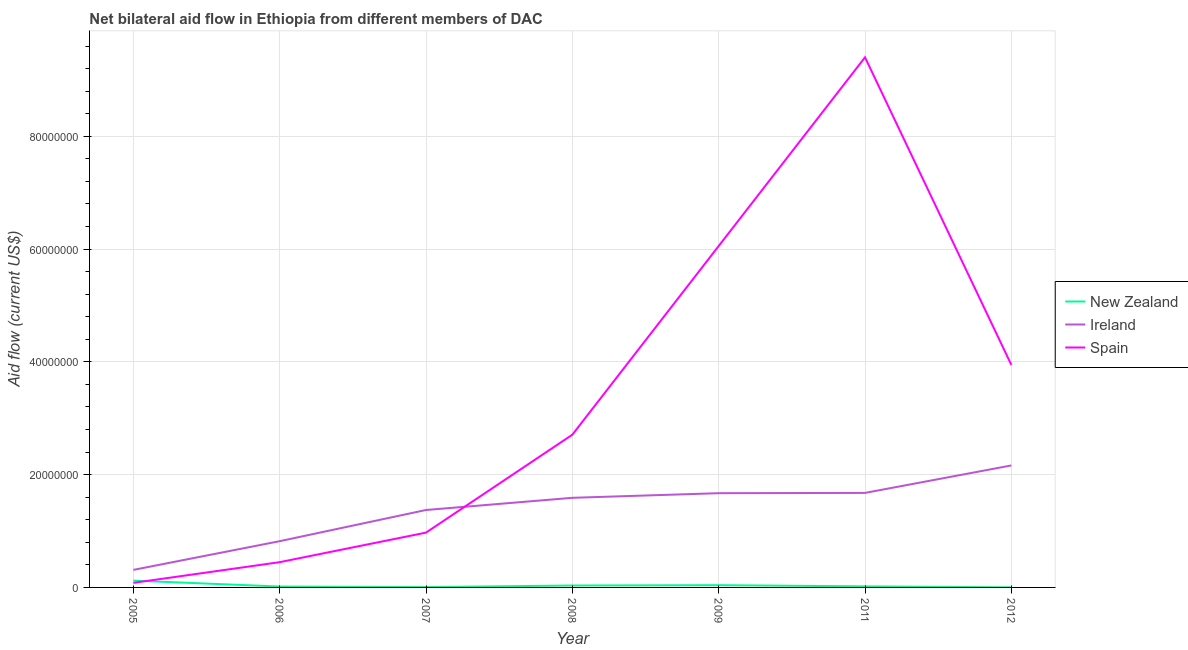What is the amount of aid provided by spain in 2008?
Your answer should be compact. 2.71e+07. Across all years, what is the maximum amount of aid provided by new zealand?
Ensure brevity in your answer.  1.21e+06. Across all years, what is the minimum amount of aid provided by new zealand?
Your answer should be compact. 2.00e+04. In which year was the amount of aid provided by spain maximum?
Make the answer very short. 2011. What is the total amount of aid provided by new zealand in the graph?
Offer a very short reply. 2.38e+06. What is the difference between the amount of aid provided by spain in 2009 and that in 2012?
Ensure brevity in your answer.  2.11e+07. What is the difference between the amount of aid provided by spain in 2007 and the amount of aid provided by new zealand in 2011?
Give a very brief answer. 9.53e+06. In the year 2007, what is the difference between the amount of aid provided by spain and amount of aid provided by new zealand?
Give a very brief answer. 9.66e+06. In how many years, is the amount of aid provided by new zealand greater than 28000000 US$?
Offer a very short reply. 0. What is the ratio of the amount of aid provided by spain in 2005 to that in 2007?
Make the answer very short. 0.08. Is the amount of aid provided by new zealand in 2008 less than that in 2012?
Give a very brief answer. No. Is the difference between the amount of aid provided by spain in 2011 and 2012 greater than the difference between the amount of aid provided by ireland in 2011 and 2012?
Ensure brevity in your answer.  Yes. What is the difference between the highest and the second highest amount of aid provided by new zealand?
Ensure brevity in your answer.  8.10e+05. What is the difference between the highest and the lowest amount of aid provided by ireland?
Provide a succinct answer. 1.85e+07. In how many years, is the amount of aid provided by new zealand greater than the average amount of aid provided by new zealand taken over all years?
Offer a very short reply. 2. Is it the case that in every year, the sum of the amount of aid provided by new zealand and amount of aid provided by ireland is greater than the amount of aid provided by spain?
Offer a terse response. No. Does the amount of aid provided by ireland monotonically increase over the years?
Your answer should be very brief. Yes. Is the amount of aid provided by ireland strictly less than the amount of aid provided by spain over the years?
Offer a very short reply. No. How many lines are there?
Your answer should be compact. 3. How many years are there in the graph?
Your response must be concise. 7. What is the difference between two consecutive major ticks on the Y-axis?
Your response must be concise. 2.00e+07. Are the values on the major ticks of Y-axis written in scientific E-notation?
Ensure brevity in your answer.  No. Does the graph contain any zero values?
Your response must be concise. No. Does the graph contain grids?
Provide a short and direct response. Yes. Where does the legend appear in the graph?
Your response must be concise. Center right. How many legend labels are there?
Keep it short and to the point. 3. What is the title of the graph?
Ensure brevity in your answer.  Net bilateral aid flow in Ethiopia from different members of DAC. What is the Aid flow (current US$) of New Zealand in 2005?
Your response must be concise. 1.21e+06. What is the Aid flow (current US$) in Ireland in 2005?
Ensure brevity in your answer.  3.11e+06. What is the Aid flow (current US$) in Spain in 2005?
Your answer should be very brief. 8.10e+05. What is the Aid flow (current US$) in New Zealand in 2006?
Your response must be concise. 1.60e+05. What is the Aid flow (current US$) in Ireland in 2006?
Offer a very short reply. 8.20e+06. What is the Aid flow (current US$) of Spain in 2006?
Provide a short and direct response. 4.48e+06. What is the Aid flow (current US$) in Ireland in 2007?
Your response must be concise. 1.37e+07. What is the Aid flow (current US$) of Spain in 2007?
Offer a very short reply. 9.72e+06. What is the Aid flow (current US$) of New Zealand in 2008?
Your answer should be compact. 3.40e+05. What is the Aid flow (current US$) in Ireland in 2008?
Your answer should be compact. 1.59e+07. What is the Aid flow (current US$) of Spain in 2008?
Ensure brevity in your answer.  2.71e+07. What is the Aid flow (current US$) of Ireland in 2009?
Ensure brevity in your answer.  1.67e+07. What is the Aid flow (current US$) of Spain in 2009?
Make the answer very short. 6.05e+07. What is the Aid flow (current US$) in New Zealand in 2011?
Offer a terse response. 1.90e+05. What is the Aid flow (current US$) in Ireland in 2011?
Give a very brief answer. 1.68e+07. What is the Aid flow (current US$) in Spain in 2011?
Provide a succinct answer. 9.40e+07. What is the Aid flow (current US$) in New Zealand in 2012?
Keep it short and to the point. 2.00e+04. What is the Aid flow (current US$) in Ireland in 2012?
Ensure brevity in your answer.  2.16e+07. What is the Aid flow (current US$) of Spain in 2012?
Provide a short and direct response. 3.95e+07. Across all years, what is the maximum Aid flow (current US$) of New Zealand?
Offer a very short reply. 1.21e+06. Across all years, what is the maximum Aid flow (current US$) in Ireland?
Offer a terse response. 2.16e+07. Across all years, what is the maximum Aid flow (current US$) in Spain?
Your answer should be very brief. 9.40e+07. Across all years, what is the minimum Aid flow (current US$) in New Zealand?
Make the answer very short. 2.00e+04. Across all years, what is the minimum Aid flow (current US$) of Ireland?
Offer a terse response. 3.11e+06. Across all years, what is the minimum Aid flow (current US$) in Spain?
Give a very brief answer. 8.10e+05. What is the total Aid flow (current US$) of New Zealand in the graph?
Your response must be concise. 2.38e+06. What is the total Aid flow (current US$) in Ireland in the graph?
Your answer should be very brief. 9.60e+07. What is the total Aid flow (current US$) in Spain in the graph?
Offer a terse response. 2.36e+08. What is the difference between the Aid flow (current US$) in New Zealand in 2005 and that in 2006?
Make the answer very short. 1.05e+06. What is the difference between the Aid flow (current US$) of Ireland in 2005 and that in 2006?
Provide a succinct answer. -5.09e+06. What is the difference between the Aid flow (current US$) of Spain in 2005 and that in 2006?
Keep it short and to the point. -3.67e+06. What is the difference between the Aid flow (current US$) of New Zealand in 2005 and that in 2007?
Offer a very short reply. 1.15e+06. What is the difference between the Aid flow (current US$) in Ireland in 2005 and that in 2007?
Your response must be concise. -1.06e+07. What is the difference between the Aid flow (current US$) of Spain in 2005 and that in 2007?
Make the answer very short. -8.91e+06. What is the difference between the Aid flow (current US$) in New Zealand in 2005 and that in 2008?
Your answer should be very brief. 8.70e+05. What is the difference between the Aid flow (current US$) in Ireland in 2005 and that in 2008?
Offer a very short reply. -1.28e+07. What is the difference between the Aid flow (current US$) of Spain in 2005 and that in 2008?
Your response must be concise. -2.63e+07. What is the difference between the Aid flow (current US$) of New Zealand in 2005 and that in 2009?
Provide a short and direct response. 8.10e+05. What is the difference between the Aid flow (current US$) of Ireland in 2005 and that in 2009?
Your response must be concise. -1.36e+07. What is the difference between the Aid flow (current US$) of Spain in 2005 and that in 2009?
Give a very brief answer. -5.97e+07. What is the difference between the Aid flow (current US$) in New Zealand in 2005 and that in 2011?
Give a very brief answer. 1.02e+06. What is the difference between the Aid flow (current US$) of Ireland in 2005 and that in 2011?
Make the answer very short. -1.36e+07. What is the difference between the Aid flow (current US$) in Spain in 2005 and that in 2011?
Keep it short and to the point. -9.32e+07. What is the difference between the Aid flow (current US$) of New Zealand in 2005 and that in 2012?
Your answer should be very brief. 1.19e+06. What is the difference between the Aid flow (current US$) in Ireland in 2005 and that in 2012?
Make the answer very short. -1.85e+07. What is the difference between the Aid flow (current US$) in Spain in 2005 and that in 2012?
Ensure brevity in your answer.  -3.86e+07. What is the difference between the Aid flow (current US$) in New Zealand in 2006 and that in 2007?
Provide a short and direct response. 1.00e+05. What is the difference between the Aid flow (current US$) of Ireland in 2006 and that in 2007?
Offer a very short reply. -5.53e+06. What is the difference between the Aid flow (current US$) in Spain in 2006 and that in 2007?
Offer a terse response. -5.24e+06. What is the difference between the Aid flow (current US$) in New Zealand in 2006 and that in 2008?
Provide a short and direct response. -1.80e+05. What is the difference between the Aid flow (current US$) in Ireland in 2006 and that in 2008?
Your answer should be compact. -7.69e+06. What is the difference between the Aid flow (current US$) in Spain in 2006 and that in 2008?
Your response must be concise. -2.26e+07. What is the difference between the Aid flow (current US$) of Ireland in 2006 and that in 2009?
Give a very brief answer. -8.51e+06. What is the difference between the Aid flow (current US$) of Spain in 2006 and that in 2009?
Your answer should be very brief. -5.61e+07. What is the difference between the Aid flow (current US$) in Ireland in 2006 and that in 2011?
Your answer should be compact. -8.56e+06. What is the difference between the Aid flow (current US$) of Spain in 2006 and that in 2011?
Provide a succinct answer. -8.95e+07. What is the difference between the Aid flow (current US$) of New Zealand in 2006 and that in 2012?
Your answer should be compact. 1.40e+05. What is the difference between the Aid flow (current US$) of Ireland in 2006 and that in 2012?
Offer a terse response. -1.34e+07. What is the difference between the Aid flow (current US$) in Spain in 2006 and that in 2012?
Your response must be concise. -3.50e+07. What is the difference between the Aid flow (current US$) in New Zealand in 2007 and that in 2008?
Make the answer very short. -2.80e+05. What is the difference between the Aid flow (current US$) in Ireland in 2007 and that in 2008?
Provide a succinct answer. -2.16e+06. What is the difference between the Aid flow (current US$) of Spain in 2007 and that in 2008?
Your answer should be compact. -1.74e+07. What is the difference between the Aid flow (current US$) of Ireland in 2007 and that in 2009?
Offer a terse response. -2.98e+06. What is the difference between the Aid flow (current US$) of Spain in 2007 and that in 2009?
Provide a succinct answer. -5.08e+07. What is the difference between the Aid flow (current US$) in New Zealand in 2007 and that in 2011?
Your response must be concise. -1.30e+05. What is the difference between the Aid flow (current US$) in Ireland in 2007 and that in 2011?
Ensure brevity in your answer.  -3.03e+06. What is the difference between the Aid flow (current US$) in Spain in 2007 and that in 2011?
Provide a short and direct response. -8.43e+07. What is the difference between the Aid flow (current US$) of Ireland in 2007 and that in 2012?
Your response must be concise. -7.90e+06. What is the difference between the Aid flow (current US$) in Spain in 2007 and that in 2012?
Your response must be concise. -2.97e+07. What is the difference between the Aid flow (current US$) of Ireland in 2008 and that in 2009?
Ensure brevity in your answer.  -8.20e+05. What is the difference between the Aid flow (current US$) in Spain in 2008 and that in 2009?
Provide a short and direct response. -3.35e+07. What is the difference between the Aid flow (current US$) in New Zealand in 2008 and that in 2011?
Your answer should be compact. 1.50e+05. What is the difference between the Aid flow (current US$) in Ireland in 2008 and that in 2011?
Your answer should be very brief. -8.70e+05. What is the difference between the Aid flow (current US$) in Spain in 2008 and that in 2011?
Provide a succinct answer. -6.69e+07. What is the difference between the Aid flow (current US$) in New Zealand in 2008 and that in 2012?
Make the answer very short. 3.20e+05. What is the difference between the Aid flow (current US$) of Ireland in 2008 and that in 2012?
Keep it short and to the point. -5.74e+06. What is the difference between the Aid flow (current US$) of Spain in 2008 and that in 2012?
Offer a terse response. -1.24e+07. What is the difference between the Aid flow (current US$) in Ireland in 2009 and that in 2011?
Your answer should be compact. -5.00e+04. What is the difference between the Aid flow (current US$) of Spain in 2009 and that in 2011?
Provide a succinct answer. -3.35e+07. What is the difference between the Aid flow (current US$) of Ireland in 2009 and that in 2012?
Your answer should be compact. -4.92e+06. What is the difference between the Aid flow (current US$) in Spain in 2009 and that in 2012?
Your response must be concise. 2.11e+07. What is the difference between the Aid flow (current US$) in New Zealand in 2011 and that in 2012?
Provide a succinct answer. 1.70e+05. What is the difference between the Aid flow (current US$) in Ireland in 2011 and that in 2012?
Your response must be concise. -4.87e+06. What is the difference between the Aid flow (current US$) in Spain in 2011 and that in 2012?
Offer a very short reply. 5.45e+07. What is the difference between the Aid flow (current US$) in New Zealand in 2005 and the Aid flow (current US$) in Ireland in 2006?
Your answer should be very brief. -6.99e+06. What is the difference between the Aid flow (current US$) in New Zealand in 2005 and the Aid flow (current US$) in Spain in 2006?
Offer a terse response. -3.27e+06. What is the difference between the Aid flow (current US$) of Ireland in 2005 and the Aid flow (current US$) of Spain in 2006?
Provide a succinct answer. -1.37e+06. What is the difference between the Aid flow (current US$) of New Zealand in 2005 and the Aid flow (current US$) of Ireland in 2007?
Offer a very short reply. -1.25e+07. What is the difference between the Aid flow (current US$) of New Zealand in 2005 and the Aid flow (current US$) of Spain in 2007?
Provide a short and direct response. -8.51e+06. What is the difference between the Aid flow (current US$) in Ireland in 2005 and the Aid flow (current US$) in Spain in 2007?
Your answer should be very brief. -6.61e+06. What is the difference between the Aid flow (current US$) of New Zealand in 2005 and the Aid flow (current US$) of Ireland in 2008?
Your answer should be compact. -1.47e+07. What is the difference between the Aid flow (current US$) in New Zealand in 2005 and the Aid flow (current US$) in Spain in 2008?
Provide a short and direct response. -2.59e+07. What is the difference between the Aid flow (current US$) in Ireland in 2005 and the Aid flow (current US$) in Spain in 2008?
Offer a terse response. -2.40e+07. What is the difference between the Aid flow (current US$) in New Zealand in 2005 and the Aid flow (current US$) in Ireland in 2009?
Your response must be concise. -1.55e+07. What is the difference between the Aid flow (current US$) in New Zealand in 2005 and the Aid flow (current US$) in Spain in 2009?
Make the answer very short. -5.93e+07. What is the difference between the Aid flow (current US$) of Ireland in 2005 and the Aid flow (current US$) of Spain in 2009?
Keep it short and to the point. -5.74e+07. What is the difference between the Aid flow (current US$) of New Zealand in 2005 and the Aid flow (current US$) of Ireland in 2011?
Your answer should be very brief. -1.56e+07. What is the difference between the Aid flow (current US$) in New Zealand in 2005 and the Aid flow (current US$) in Spain in 2011?
Keep it short and to the point. -9.28e+07. What is the difference between the Aid flow (current US$) of Ireland in 2005 and the Aid flow (current US$) of Spain in 2011?
Keep it short and to the point. -9.09e+07. What is the difference between the Aid flow (current US$) in New Zealand in 2005 and the Aid flow (current US$) in Ireland in 2012?
Your response must be concise. -2.04e+07. What is the difference between the Aid flow (current US$) in New Zealand in 2005 and the Aid flow (current US$) in Spain in 2012?
Offer a terse response. -3.82e+07. What is the difference between the Aid flow (current US$) in Ireland in 2005 and the Aid flow (current US$) in Spain in 2012?
Your response must be concise. -3.64e+07. What is the difference between the Aid flow (current US$) in New Zealand in 2006 and the Aid flow (current US$) in Ireland in 2007?
Your response must be concise. -1.36e+07. What is the difference between the Aid flow (current US$) of New Zealand in 2006 and the Aid flow (current US$) of Spain in 2007?
Give a very brief answer. -9.56e+06. What is the difference between the Aid flow (current US$) of Ireland in 2006 and the Aid flow (current US$) of Spain in 2007?
Make the answer very short. -1.52e+06. What is the difference between the Aid flow (current US$) in New Zealand in 2006 and the Aid flow (current US$) in Ireland in 2008?
Offer a terse response. -1.57e+07. What is the difference between the Aid flow (current US$) of New Zealand in 2006 and the Aid flow (current US$) of Spain in 2008?
Provide a short and direct response. -2.69e+07. What is the difference between the Aid flow (current US$) in Ireland in 2006 and the Aid flow (current US$) in Spain in 2008?
Offer a very short reply. -1.89e+07. What is the difference between the Aid flow (current US$) in New Zealand in 2006 and the Aid flow (current US$) in Ireland in 2009?
Provide a short and direct response. -1.66e+07. What is the difference between the Aid flow (current US$) of New Zealand in 2006 and the Aid flow (current US$) of Spain in 2009?
Ensure brevity in your answer.  -6.04e+07. What is the difference between the Aid flow (current US$) in Ireland in 2006 and the Aid flow (current US$) in Spain in 2009?
Ensure brevity in your answer.  -5.23e+07. What is the difference between the Aid flow (current US$) of New Zealand in 2006 and the Aid flow (current US$) of Ireland in 2011?
Provide a short and direct response. -1.66e+07. What is the difference between the Aid flow (current US$) in New Zealand in 2006 and the Aid flow (current US$) in Spain in 2011?
Give a very brief answer. -9.38e+07. What is the difference between the Aid flow (current US$) in Ireland in 2006 and the Aid flow (current US$) in Spain in 2011?
Offer a very short reply. -8.58e+07. What is the difference between the Aid flow (current US$) in New Zealand in 2006 and the Aid flow (current US$) in Ireland in 2012?
Give a very brief answer. -2.15e+07. What is the difference between the Aid flow (current US$) of New Zealand in 2006 and the Aid flow (current US$) of Spain in 2012?
Provide a succinct answer. -3.93e+07. What is the difference between the Aid flow (current US$) in Ireland in 2006 and the Aid flow (current US$) in Spain in 2012?
Provide a short and direct response. -3.13e+07. What is the difference between the Aid flow (current US$) in New Zealand in 2007 and the Aid flow (current US$) in Ireland in 2008?
Make the answer very short. -1.58e+07. What is the difference between the Aid flow (current US$) in New Zealand in 2007 and the Aid flow (current US$) in Spain in 2008?
Your response must be concise. -2.70e+07. What is the difference between the Aid flow (current US$) of Ireland in 2007 and the Aid flow (current US$) of Spain in 2008?
Your answer should be very brief. -1.34e+07. What is the difference between the Aid flow (current US$) of New Zealand in 2007 and the Aid flow (current US$) of Ireland in 2009?
Provide a short and direct response. -1.66e+07. What is the difference between the Aid flow (current US$) of New Zealand in 2007 and the Aid flow (current US$) of Spain in 2009?
Provide a short and direct response. -6.05e+07. What is the difference between the Aid flow (current US$) in Ireland in 2007 and the Aid flow (current US$) in Spain in 2009?
Give a very brief answer. -4.68e+07. What is the difference between the Aid flow (current US$) of New Zealand in 2007 and the Aid flow (current US$) of Ireland in 2011?
Give a very brief answer. -1.67e+07. What is the difference between the Aid flow (current US$) in New Zealand in 2007 and the Aid flow (current US$) in Spain in 2011?
Ensure brevity in your answer.  -9.39e+07. What is the difference between the Aid flow (current US$) of Ireland in 2007 and the Aid flow (current US$) of Spain in 2011?
Provide a short and direct response. -8.03e+07. What is the difference between the Aid flow (current US$) of New Zealand in 2007 and the Aid flow (current US$) of Ireland in 2012?
Give a very brief answer. -2.16e+07. What is the difference between the Aid flow (current US$) in New Zealand in 2007 and the Aid flow (current US$) in Spain in 2012?
Keep it short and to the point. -3.94e+07. What is the difference between the Aid flow (current US$) in Ireland in 2007 and the Aid flow (current US$) in Spain in 2012?
Give a very brief answer. -2.57e+07. What is the difference between the Aid flow (current US$) in New Zealand in 2008 and the Aid flow (current US$) in Ireland in 2009?
Offer a very short reply. -1.64e+07. What is the difference between the Aid flow (current US$) in New Zealand in 2008 and the Aid flow (current US$) in Spain in 2009?
Ensure brevity in your answer.  -6.02e+07. What is the difference between the Aid flow (current US$) of Ireland in 2008 and the Aid flow (current US$) of Spain in 2009?
Provide a succinct answer. -4.46e+07. What is the difference between the Aid flow (current US$) in New Zealand in 2008 and the Aid flow (current US$) in Ireland in 2011?
Your answer should be compact. -1.64e+07. What is the difference between the Aid flow (current US$) in New Zealand in 2008 and the Aid flow (current US$) in Spain in 2011?
Your answer should be very brief. -9.37e+07. What is the difference between the Aid flow (current US$) of Ireland in 2008 and the Aid flow (current US$) of Spain in 2011?
Keep it short and to the point. -7.81e+07. What is the difference between the Aid flow (current US$) in New Zealand in 2008 and the Aid flow (current US$) in Ireland in 2012?
Give a very brief answer. -2.13e+07. What is the difference between the Aid flow (current US$) in New Zealand in 2008 and the Aid flow (current US$) in Spain in 2012?
Offer a terse response. -3.91e+07. What is the difference between the Aid flow (current US$) of Ireland in 2008 and the Aid flow (current US$) of Spain in 2012?
Your response must be concise. -2.36e+07. What is the difference between the Aid flow (current US$) of New Zealand in 2009 and the Aid flow (current US$) of Ireland in 2011?
Give a very brief answer. -1.64e+07. What is the difference between the Aid flow (current US$) in New Zealand in 2009 and the Aid flow (current US$) in Spain in 2011?
Give a very brief answer. -9.36e+07. What is the difference between the Aid flow (current US$) in Ireland in 2009 and the Aid flow (current US$) in Spain in 2011?
Ensure brevity in your answer.  -7.73e+07. What is the difference between the Aid flow (current US$) of New Zealand in 2009 and the Aid flow (current US$) of Ireland in 2012?
Your response must be concise. -2.12e+07. What is the difference between the Aid flow (current US$) in New Zealand in 2009 and the Aid flow (current US$) in Spain in 2012?
Keep it short and to the point. -3.91e+07. What is the difference between the Aid flow (current US$) in Ireland in 2009 and the Aid flow (current US$) in Spain in 2012?
Provide a succinct answer. -2.28e+07. What is the difference between the Aid flow (current US$) of New Zealand in 2011 and the Aid flow (current US$) of Ireland in 2012?
Your answer should be compact. -2.14e+07. What is the difference between the Aid flow (current US$) of New Zealand in 2011 and the Aid flow (current US$) of Spain in 2012?
Provide a short and direct response. -3.93e+07. What is the difference between the Aid flow (current US$) in Ireland in 2011 and the Aid flow (current US$) in Spain in 2012?
Keep it short and to the point. -2.27e+07. What is the average Aid flow (current US$) in Ireland per year?
Ensure brevity in your answer.  1.37e+07. What is the average Aid flow (current US$) in Spain per year?
Provide a short and direct response. 3.37e+07. In the year 2005, what is the difference between the Aid flow (current US$) in New Zealand and Aid flow (current US$) in Ireland?
Provide a short and direct response. -1.90e+06. In the year 2005, what is the difference between the Aid flow (current US$) of New Zealand and Aid flow (current US$) of Spain?
Your answer should be very brief. 4.00e+05. In the year 2005, what is the difference between the Aid flow (current US$) in Ireland and Aid flow (current US$) in Spain?
Offer a very short reply. 2.30e+06. In the year 2006, what is the difference between the Aid flow (current US$) of New Zealand and Aid flow (current US$) of Ireland?
Give a very brief answer. -8.04e+06. In the year 2006, what is the difference between the Aid flow (current US$) in New Zealand and Aid flow (current US$) in Spain?
Your answer should be very brief. -4.32e+06. In the year 2006, what is the difference between the Aid flow (current US$) of Ireland and Aid flow (current US$) of Spain?
Offer a very short reply. 3.72e+06. In the year 2007, what is the difference between the Aid flow (current US$) of New Zealand and Aid flow (current US$) of Ireland?
Provide a succinct answer. -1.37e+07. In the year 2007, what is the difference between the Aid flow (current US$) of New Zealand and Aid flow (current US$) of Spain?
Keep it short and to the point. -9.66e+06. In the year 2007, what is the difference between the Aid flow (current US$) of Ireland and Aid flow (current US$) of Spain?
Your response must be concise. 4.01e+06. In the year 2008, what is the difference between the Aid flow (current US$) in New Zealand and Aid flow (current US$) in Ireland?
Offer a terse response. -1.56e+07. In the year 2008, what is the difference between the Aid flow (current US$) in New Zealand and Aid flow (current US$) in Spain?
Give a very brief answer. -2.67e+07. In the year 2008, what is the difference between the Aid flow (current US$) in Ireland and Aid flow (current US$) in Spain?
Provide a succinct answer. -1.12e+07. In the year 2009, what is the difference between the Aid flow (current US$) in New Zealand and Aid flow (current US$) in Ireland?
Your answer should be compact. -1.63e+07. In the year 2009, what is the difference between the Aid flow (current US$) of New Zealand and Aid flow (current US$) of Spain?
Give a very brief answer. -6.01e+07. In the year 2009, what is the difference between the Aid flow (current US$) of Ireland and Aid flow (current US$) of Spain?
Ensure brevity in your answer.  -4.38e+07. In the year 2011, what is the difference between the Aid flow (current US$) of New Zealand and Aid flow (current US$) of Ireland?
Your answer should be very brief. -1.66e+07. In the year 2011, what is the difference between the Aid flow (current US$) in New Zealand and Aid flow (current US$) in Spain?
Offer a terse response. -9.38e+07. In the year 2011, what is the difference between the Aid flow (current US$) of Ireland and Aid flow (current US$) of Spain?
Your answer should be compact. -7.72e+07. In the year 2012, what is the difference between the Aid flow (current US$) in New Zealand and Aid flow (current US$) in Ireland?
Offer a very short reply. -2.16e+07. In the year 2012, what is the difference between the Aid flow (current US$) of New Zealand and Aid flow (current US$) of Spain?
Provide a succinct answer. -3.94e+07. In the year 2012, what is the difference between the Aid flow (current US$) in Ireland and Aid flow (current US$) in Spain?
Offer a very short reply. -1.78e+07. What is the ratio of the Aid flow (current US$) in New Zealand in 2005 to that in 2006?
Ensure brevity in your answer.  7.56. What is the ratio of the Aid flow (current US$) of Ireland in 2005 to that in 2006?
Your answer should be very brief. 0.38. What is the ratio of the Aid flow (current US$) in Spain in 2005 to that in 2006?
Provide a short and direct response. 0.18. What is the ratio of the Aid flow (current US$) in New Zealand in 2005 to that in 2007?
Your answer should be very brief. 20.17. What is the ratio of the Aid flow (current US$) of Ireland in 2005 to that in 2007?
Offer a terse response. 0.23. What is the ratio of the Aid flow (current US$) in Spain in 2005 to that in 2007?
Offer a terse response. 0.08. What is the ratio of the Aid flow (current US$) in New Zealand in 2005 to that in 2008?
Your response must be concise. 3.56. What is the ratio of the Aid flow (current US$) of Ireland in 2005 to that in 2008?
Ensure brevity in your answer.  0.2. What is the ratio of the Aid flow (current US$) in Spain in 2005 to that in 2008?
Offer a very short reply. 0.03. What is the ratio of the Aid flow (current US$) of New Zealand in 2005 to that in 2009?
Provide a short and direct response. 3.02. What is the ratio of the Aid flow (current US$) in Ireland in 2005 to that in 2009?
Provide a succinct answer. 0.19. What is the ratio of the Aid flow (current US$) of Spain in 2005 to that in 2009?
Make the answer very short. 0.01. What is the ratio of the Aid flow (current US$) of New Zealand in 2005 to that in 2011?
Provide a succinct answer. 6.37. What is the ratio of the Aid flow (current US$) of Ireland in 2005 to that in 2011?
Offer a terse response. 0.19. What is the ratio of the Aid flow (current US$) of Spain in 2005 to that in 2011?
Your answer should be very brief. 0.01. What is the ratio of the Aid flow (current US$) of New Zealand in 2005 to that in 2012?
Offer a terse response. 60.5. What is the ratio of the Aid flow (current US$) in Ireland in 2005 to that in 2012?
Ensure brevity in your answer.  0.14. What is the ratio of the Aid flow (current US$) in Spain in 2005 to that in 2012?
Ensure brevity in your answer.  0.02. What is the ratio of the Aid flow (current US$) of New Zealand in 2006 to that in 2007?
Make the answer very short. 2.67. What is the ratio of the Aid flow (current US$) in Ireland in 2006 to that in 2007?
Offer a terse response. 0.6. What is the ratio of the Aid flow (current US$) in Spain in 2006 to that in 2007?
Make the answer very short. 0.46. What is the ratio of the Aid flow (current US$) of New Zealand in 2006 to that in 2008?
Keep it short and to the point. 0.47. What is the ratio of the Aid flow (current US$) of Ireland in 2006 to that in 2008?
Your answer should be compact. 0.52. What is the ratio of the Aid flow (current US$) of Spain in 2006 to that in 2008?
Ensure brevity in your answer.  0.17. What is the ratio of the Aid flow (current US$) in Ireland in 2006 to that in 2009?
Make the answer very short. 0.49. What is the ratio of the Aid flow (current US$) of Spain in 2006 to that in 2009?
Your answer should be compact. 0.07. What is the ratio of the Aid flow (current US$) in New Zealand in 2006 to that in 2011?
Provide a succinct answer. 0.84. What is the ratio of the Aid flow (current US$) in Ireland in 2006 to that in 2011?
Make the answer very short. 0.49. What is the ratio of the Aid flow (current US$) in Spain in 2006 to that in 2011?
Provide a short and direct response. 0.05. What is the ratio of the Aid flow (current US$) of Ireland in 2006 to that in 2012?
Provide a succinct answer. 0.38. What is the ratio of the Aid flow (current US$) of Spain in 2006 to that in 2012?
Provide a short and direct response. 0.11. What is the ratio of the Aid flow (current US$) in New Zealand in 2007 to that in 2008?
Your answer should be compact. 0.18. What is the ratio of the Aid flow (current US$) in Ireland in 2007 to that in 2008?
Make the answer very short. 0.86. What is the ratio of the Aid flow (current US$) of Spain in 2007 to that in 2008?
Ensure brevity in your answer.  0.36. What is the ratio of the Aid flow (current US$) in New Zealand in 2007 to that in 2009?
Your answer should be compact. 0.15. What is the ratio of the Aid flow (current US$) in Ireland in 2007 to that in 2009?
Offer a very short reply. 0.82. What is the ratio of the Aid flow (current US$) in Spain in 2007 to that in 2009?
Offer a very short reply. 0.16. What is the ratio of the Aid flow (current US$) of New Zealand in 2007 to that in 2011?
Ensure brevity in your answer.  0.32. What is the ratio of the Aid flow (current US$) in Ireland in 2007 to that in 2011?
Give a very brief answer. 0.82. What is the ratio of the Aid flow (current US$) in Spain in 2007 to that in 2011?
Make the answer very short. 0.1. What is the ratio of the Aid flow (current US$) in Ireland in 2007 to that in 2012?
Your answer should be very brief. 0.63. What is the ratio of the Aid flow (current US$) of Spain in 2007 to that in 2012?
Make the answer very short. 0.25. What is the ratio of the Aid flow (current US$) of Ireland in 2008 to that in 2009?
Your answer should be very brief. 0.95. What is the ratio of the Aid flow (current US$) in Spain in 2008 to that in 2009?
Make the answer very short. 0.45. What is the ratio of the Aid flow (current US$) in New Zealand in 2008 to that in 2011?
Offer a terse response. 1.79. What is the ratio of the Aid flow (current US$) in Ireland in 2008 to that in 2011?
Provide a short and direct response. 0.95. What is the ratio of the Aid flow (current US$) of Spain in 2008 to that in 2011?
Provide a short and direct response. 0.29. What is the ratio of the Aid flow (current US$) of New Zealand in 2008 to that in 2012?
Offer a very short reply. 17. What is the ratio of the Aid flow (current US$) of Ireland in 2008 to that in 2012?
Offer a very short reply. 0.73. What is the ratio of the Aid flow (current US$) of Spain in 2008 to that in 2012?
Provide a succinct answer. 0.69. What is the ratio of the Aid flow (current US$) of New Zealand in 2009 to that in 2011?
Offer a terse response. 2.11. What is the ratio of the Aid flow (current US$) of Spain in 2009 to that in 2011?
Make the answer very short. 0.64. What is the ratio of the Aid flow (current US$) in Ireland in 2009 to that in 2012?
Ensure brevity in your answer.  0.77. What is the ratio of the Aid flow (current US$) of Spain in 2009 to that in 2012?
Your answer should be compact. 1.53. What is the ratio of the Aid flow (current US$) in New Zealand in 2011 to that in 2012?
Offer a very short reply. 9.5. What is the ratio of the Aid flow (current US$) of Ireland in 2011 to that in 2012?
Provide a succinct answer. 0.77. What is the ratio of the Aid flow (current US$) in Spain in 2011 to that in 2012?
Keep it short and to the point. 2.38. What is the difference between the highest and the second highest Aid flow (current US$) in New Zealand?
Make the answer very short. 8.10e+05. What is the difference between the highest and the second highest Aid flow (current US$) in Ireland?
Provide a succinct answer. 4.87e+06. What is the difference between the highest and the second highest Aid flow (current US$) of Spain?
Offer a terse response. 3.35e+07. What is the difference between the highest and the lowest Aid flow (current US$) in New Zealand?
Make the answer very short. 1.19e+06. What is the difference between the highest and the lowest Aid flow (current US$) of Ireland?
Your answer should be compact. 1.85e+07. What is the difference between the highest and the lowest Aid flow (current US$) of Spain?
Ensure brevity in your answer.  9.32e+07. 